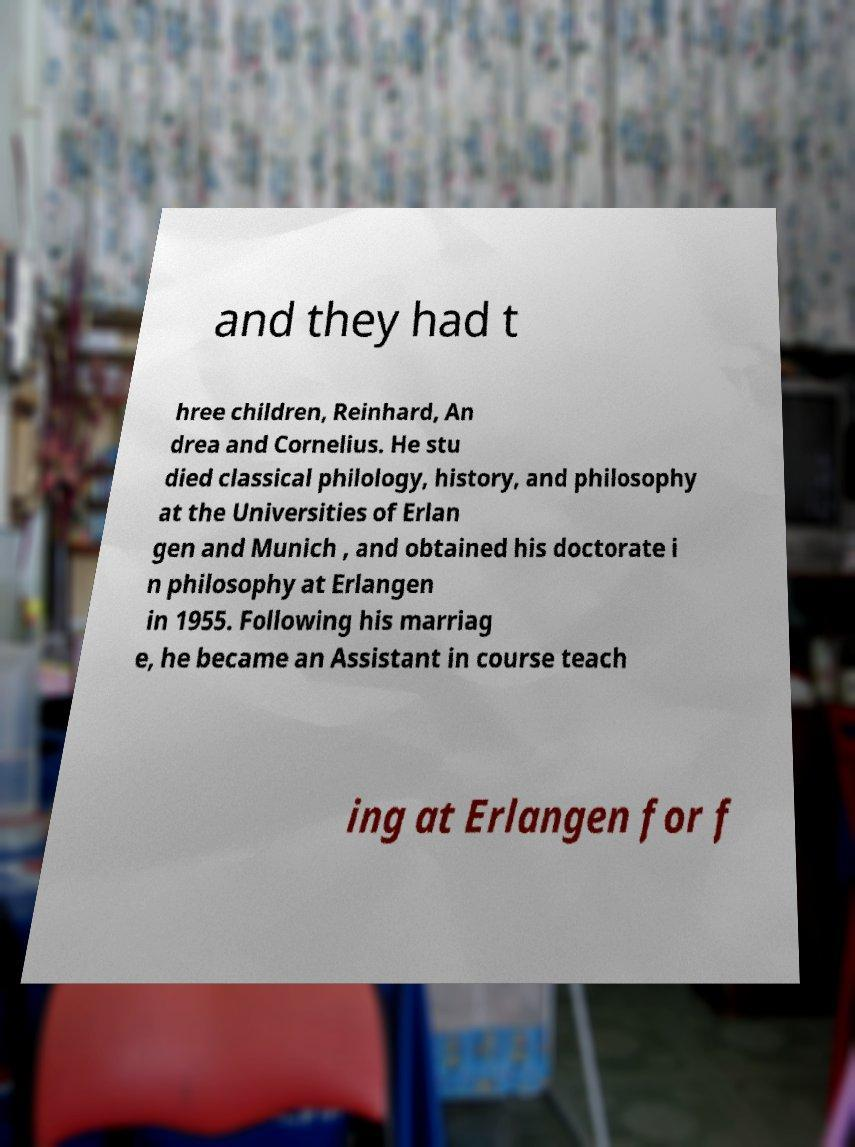Can you accurately transcribe the text from the provided image for me? and they had t hree children, Reinhard, An drea and Cornelius. He stu died classical philology, history, and philosophy at the Universities of Erlan gen and Munich , and obtained his doctorate i n philosophy at Erlangen in 1955. Following his marriag e, he became an Assistant in course teach ing at Erlangen for f 